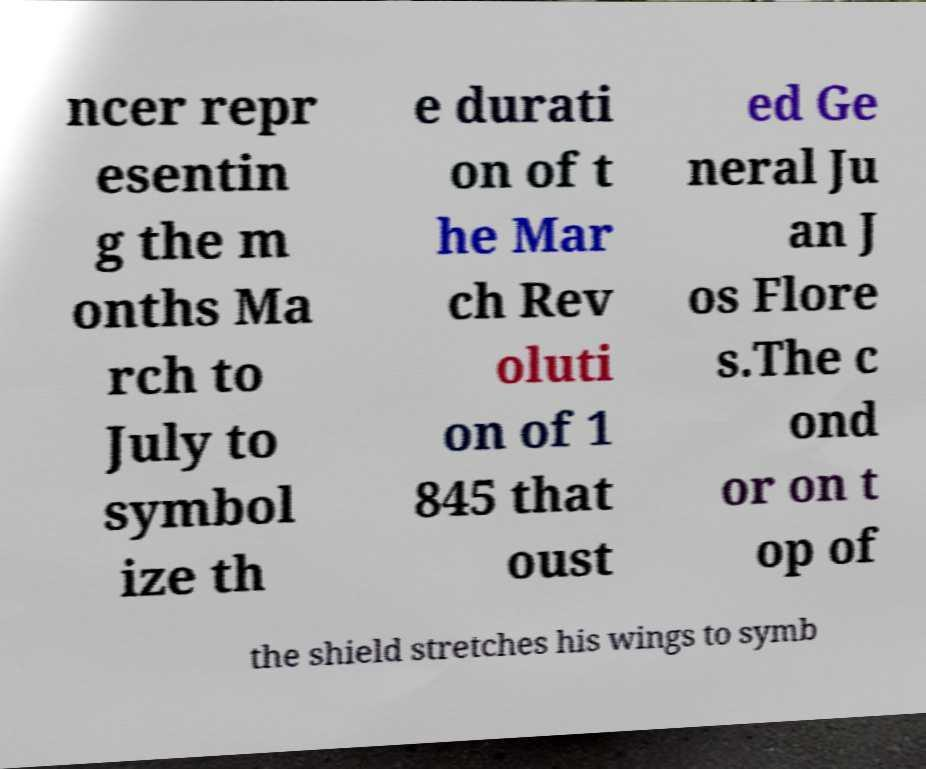Can you read and provide the text displayed in the image?This photo seems to have some interesting text. Can you extract and type it out for me? ncer repr esentin g the m onths Ma rch to July to symbol ize th e durati on of t he Mar ch Rev oluti on of 1 845 that oust ed Ge neral Ju an J os Flore s.The c ond or on t op of the shield stretches his wings to symb 